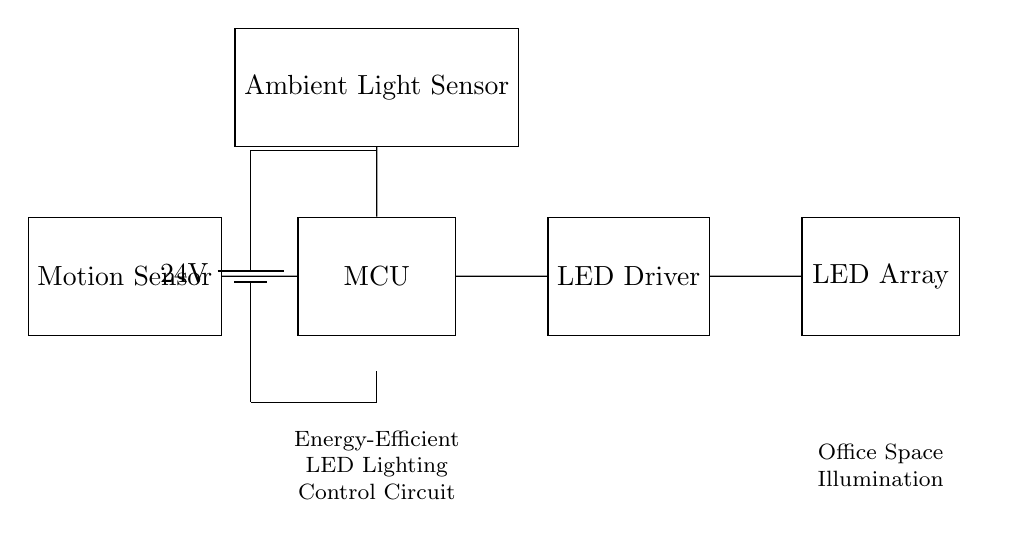What is the voltage of this circuit? The circuit shows a battery component labeled as 24V, indicating that the power supply voltage is 24 volts.
Answer: 24 volts What components are connected to the microcontroller? The microcontroller is connected to a motion sensor and an ambient light sensor, which send input data to the MCU for processing.
Answer: Motion sensor and ambient light sensor What is the purpose of the LED driver in this circuit? The LED driver regulates the power delivered to the LED array, ensuring that it operates efficiently and at the correct voltage and current for optimal performance.
Answer: Regulates power to LEDs How many sensors are present in this circuit? The circuit includes two sensors: one motion sensor and one ambient light sensor, which are used to detect occupancy and light levels.
Answer: Two sensors How does the ambient light sensor influence the lighting operation? The ambient light sensor detects the surrounding light levels and sends this information to the microcontroller, which uses it to adjust the LED brightness accordingly, conserving energy when natural light is sufficient.
Answer: Adjusts LED brightness based on light levels What is the main application of this circuit? The primary application of this circuit is to control energy-efficient LED lighting in office spaces, providing illumination based on occupancy and ambient conditions.
Answer: Office space illumination 